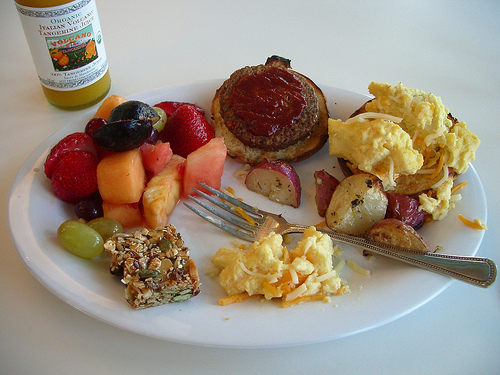<image>
Is there a grape on the plate? Yes. Looking at the image, I can see the grape is positioned on top of the plate, with the plate providing support. 